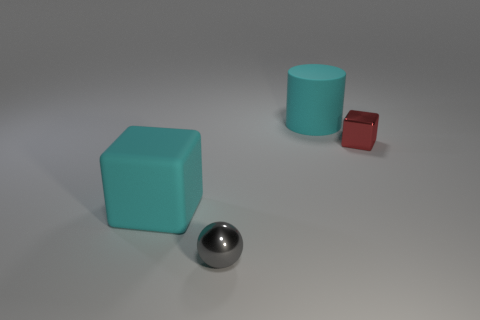Subtract 0 red spheres. How many objects are left? 4 Subtract all cylinders. How many objects are left? 3 Subtract all green balls. Subtract all green cylinders. How many balls are left? 1 Subtract all green balls. How many blue cylinders are left? 0 Subtract all cyan matte objects. Subtract all small blocks. How many objects are left? 1 Add 1 small spheres. How many small spheres are left? 2 Add 2 tiny red shiny things. How many tiny red shiny things exist? 3 Add 2 tiny gray objects. How many objects exist? 6 Subtract all red blocks. How many blocks are left? 1 